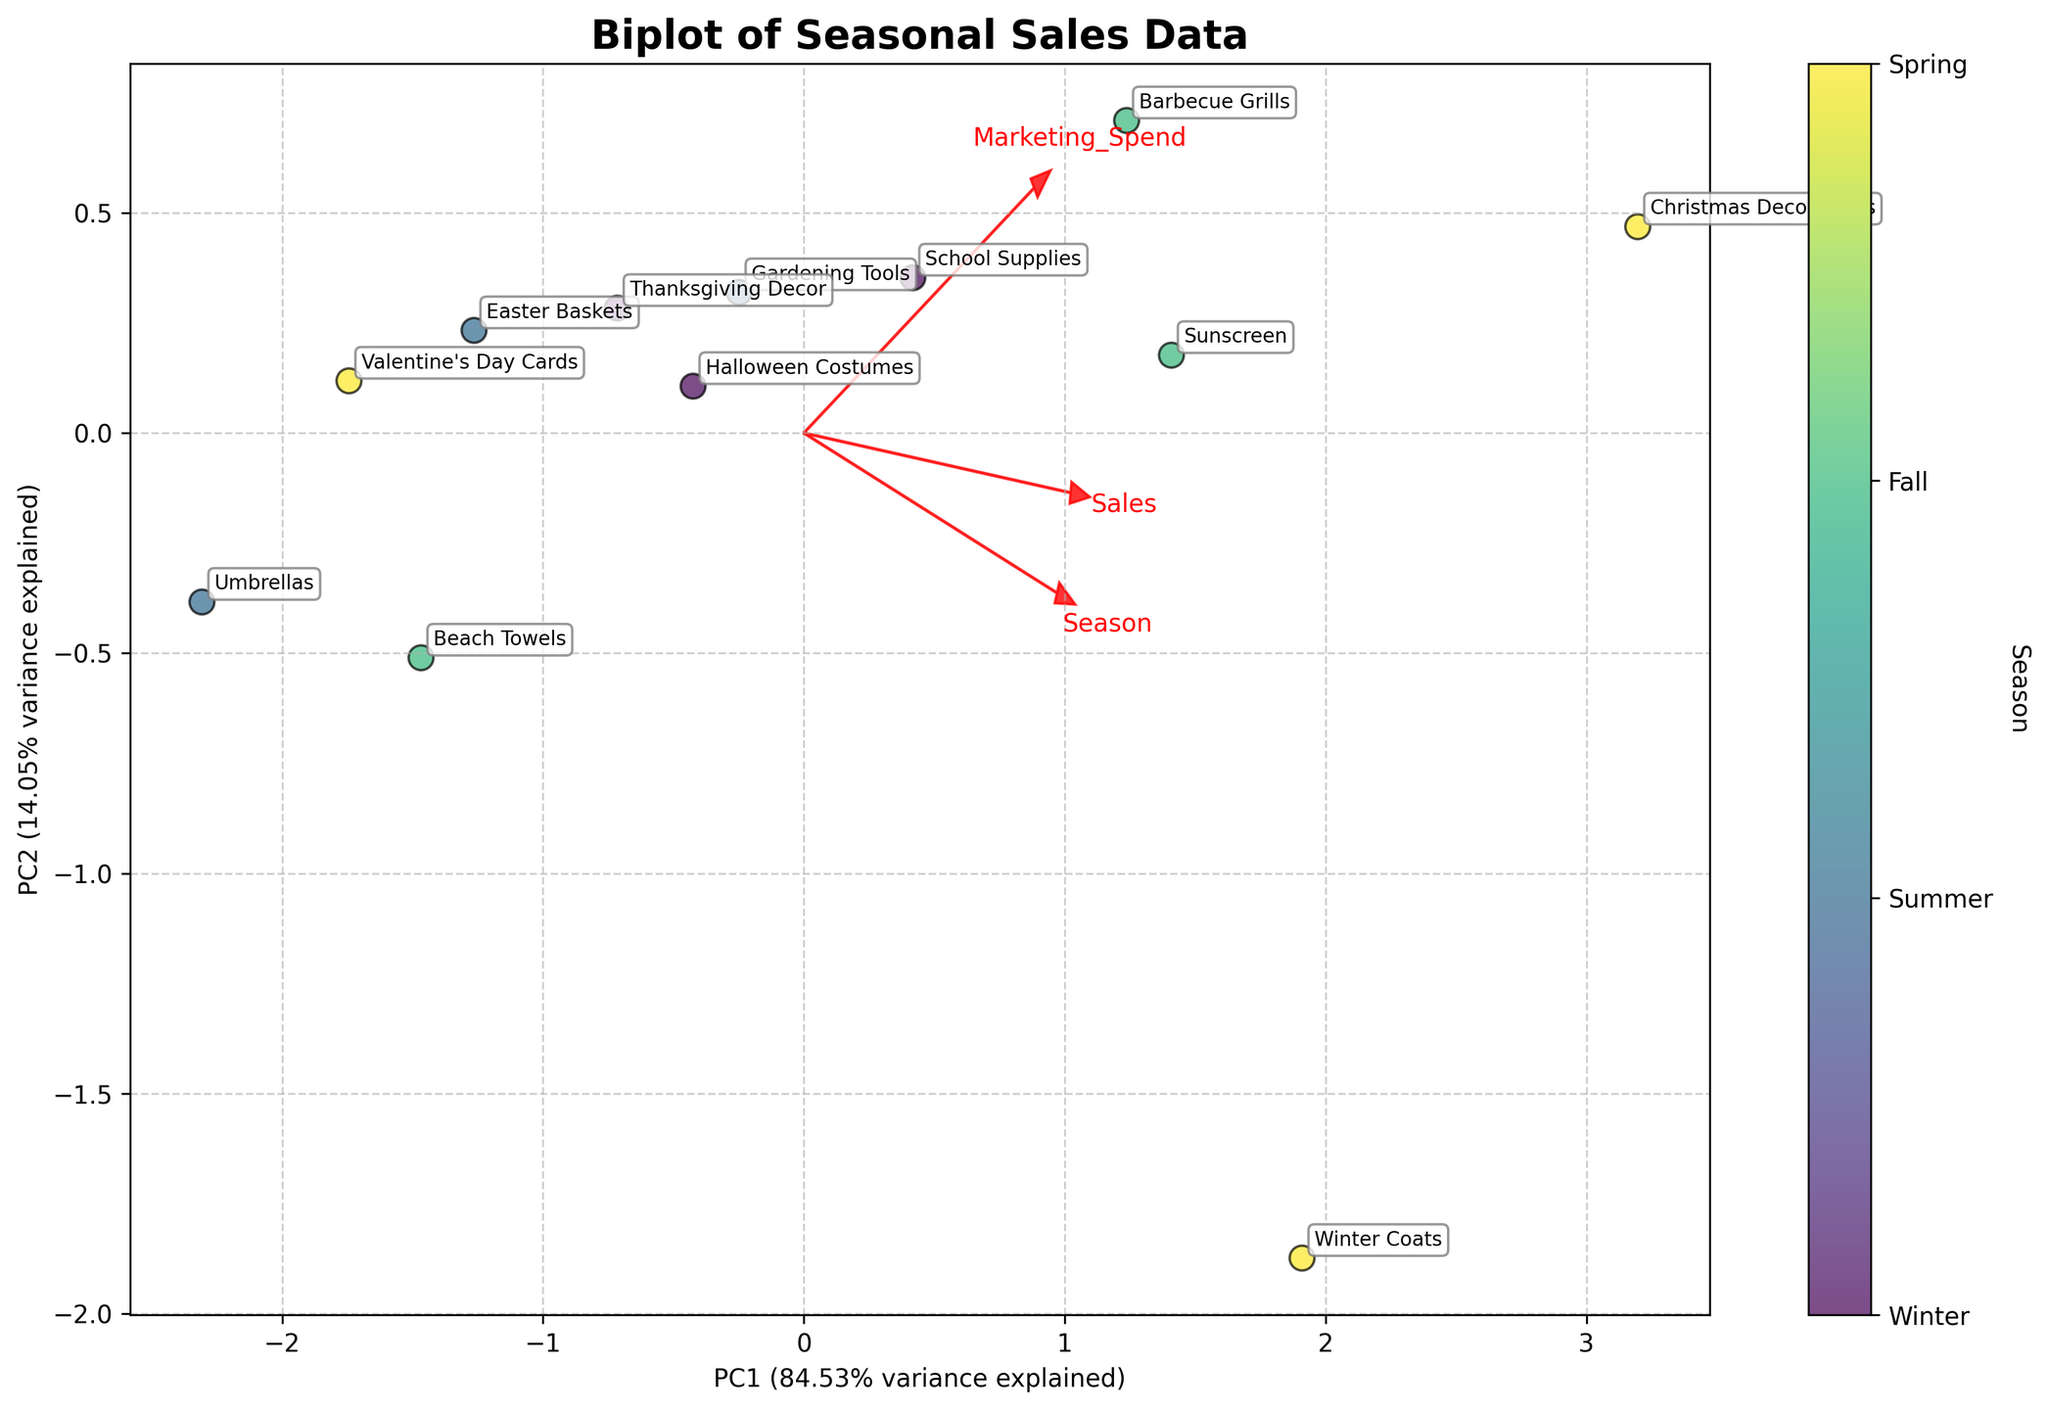How many seasons are represented in the plot? By identifying the colors in the plot which indicate different seasons, one can count the number of unique seasons depicted. The color legend usually specifies each season.
Answer: 4 What is the title of the plot? The title is usually located at the top of the plot in a larger font size compared to other text elements. It summarizes the main focus of the plot.
Answer: Biplot of Seasonal Sales Data Which product is positioned closest to the origin point (0,0) in the plot? The origin point (0,0) is the center of the plot where the x-axis and y-axis intersect. By assessing the distances of data points from this center, the product closest to it can be identified.
Answer: Umbrellas Which product has the highest customer satisfaction, and which season does it belong to? By looking at the product names and their associated customer satisfaction scores in the plot, one can identify the product with the highest satisfaction score. The color or the label next to the point will indicate the season.
Answer: Christmas Decorations, Winter What is the variance explained by the first principal component (PC1)? The variance explained by PC1 is usually mentioned in the x-axis label as a percentage.
Answer: 54.93% Which direction does the arrow for "Sales" point to, and what does it indicate? By analyzing the plot, the arrow labeled "Sales" can be observed for its direction. The direction can be described by the angle it makes with the axes, indicating how sales contribute to the principal components.
Answer: Right and slightly upwards, indicates that higher sales are associated with positive values in PC1 and PC2 How are "Marketing Spend" and "Customer Satisfaction" related based on the loadings in the plot? The arrows for "Marketing Spend" and "Customer Satisfaction" can be compared to see if they point in similar or opposite directions. Similar directions suggest a positive correlation, while opposite directions suggest a negative correlation.
Answer: Positively correlated; both arrows point in similar directions Which season shows the most variance in the sales data points? The variance within each season can be inferred by observing the spread of data points that share the same seasonal color. The season with the largest scatter of points represents the most variance.
Answer: Winter How do the positions of "Front-of-store" products compare to those of "Mid-aisle" products? By identifying the products placed in "Front-of-store" and "Mid-aisle", their positions on the plot can be compared. This helps in understanding if either location correlates with higher or lower principal component scores.
Answer: Front-of-store products are generally spread out more, indicating variability, while Mid-aisle products tend to cluster Is "Easter Baskets" more influenced by marketing spend or customer satisfaction according to the plot? By checking the position of "Easter Baskets" relative to the arrows for "Marketing Spend" and "Customer Satisfaction," the closer arrow indicates which variable has a greater influence.
Answer: Customer Satisfaction 